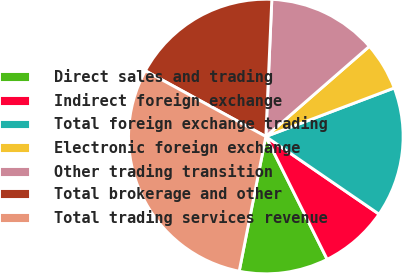<chart> <loc_0><loc_0><loc_500><loc_500><pie_chart><fcel>Direct sales and trading<fcel>Indirect foreign exchange<fcel>Total foreign exchange trading<fcel>Electronic foreign exchange<fcel>Other trading transition<fcel>Total brokerage and other<fcel>Total trading services revenue<nl><fcel>10.48%<fcel>8.06%<fcel>15.32%<fcel>5.65%<fcel>12.9%<fcel>17.74%<fcel>29.84%<nl></chart> 